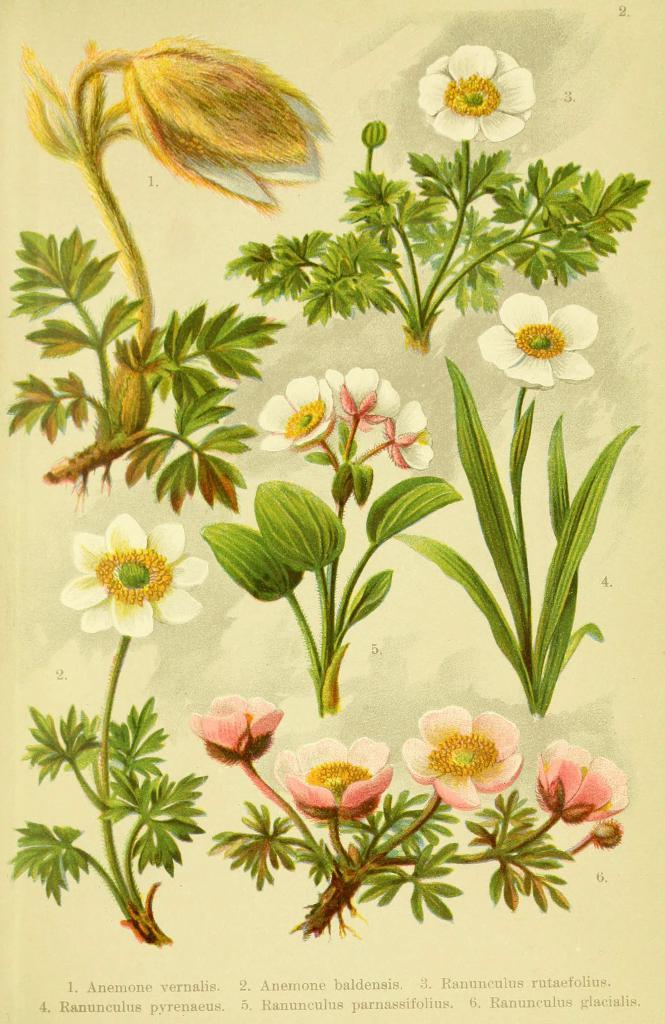What type of drawings are present in the image? The image contains drawings of plants. How many different species of plants are depicted in the drawings? The drawings depict different species of plants. What can be observed about the colors of the plants in the drawings? The plants have different colors in the drawings. Where is the text located in the image? There is text at the bottom of the image. Can you see a robin's heart in the image? There is no robin or heart present in the image; it contains drawings of plants. 